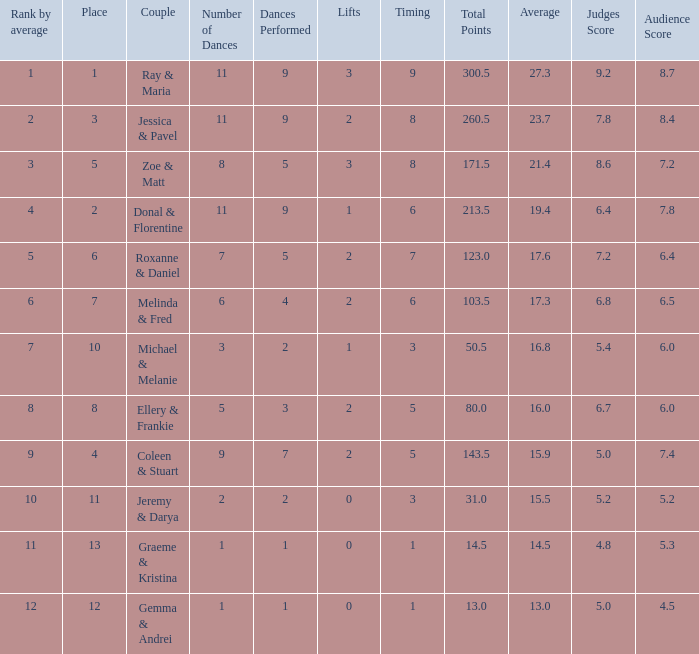If the total points is 50.5, what is the total number of dances? 1.0. 